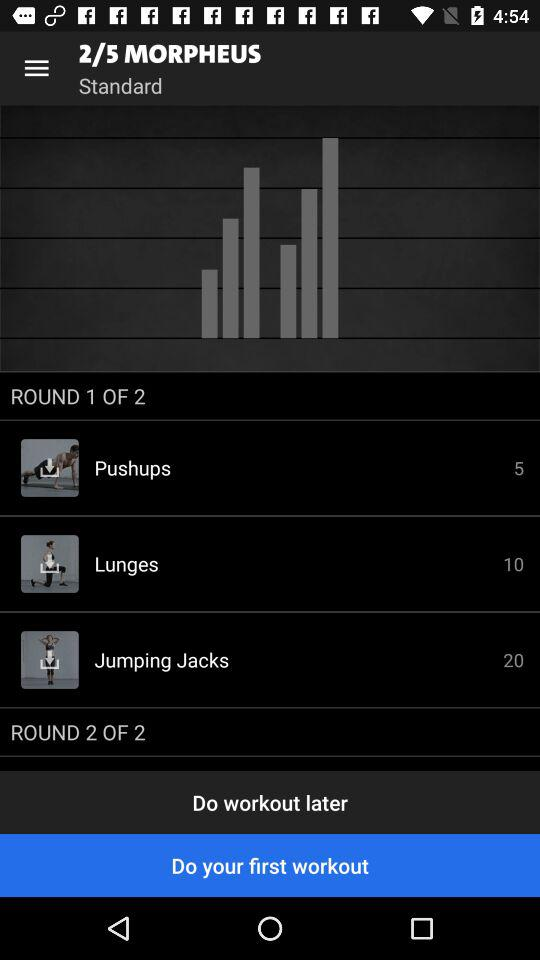Which exercises are in round 2?
When the provided information is insufficient, respond with <no answer>. <no answer> 